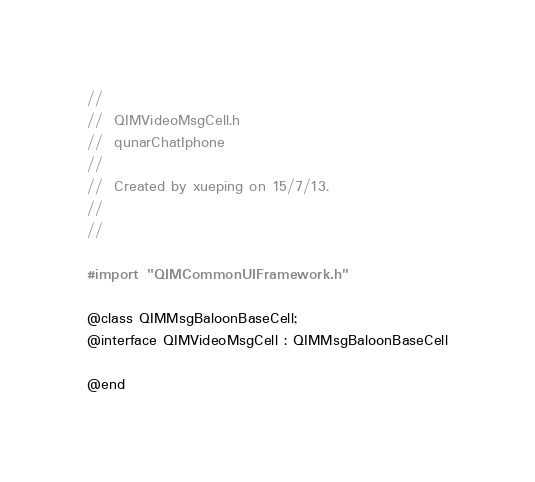<code> <loc_0><loc_0><loc_500><loc_500><_C_>//
//  QIMVideoMsgCell.h
//  qunarChatIphone
//
//  Created by xueping on 15/7/13.
//
//

#import "QIMCommonUIFramework.h"

@class QIMMsgBaloonBaseCell;
@interface QIMVideoMsgCell : QIMMsgBaloonBaseCell

@end
</code> 